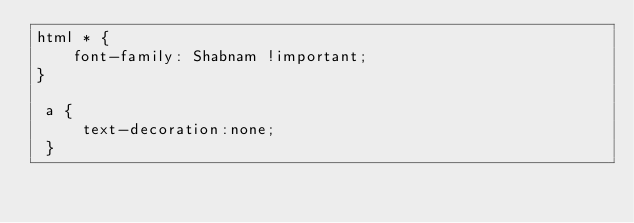Convert code to text. <code><loc_0><loc_0><loc_500><loc_500><_CSS_>html * {
    font-family: Shabnam !important;
}

 a {
     text-decoration:none;
 }</code> 